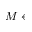<formula> <loc_0><loc_0><loc_500><loc_500>M \gets</formula> 